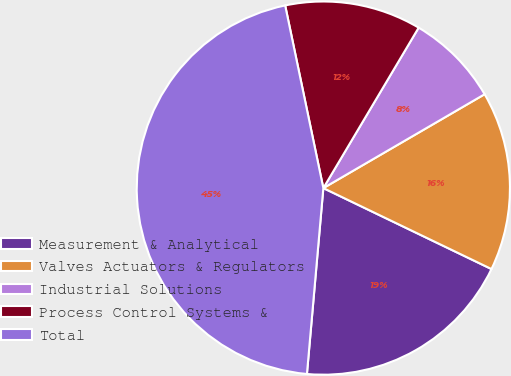<chart> <loc_0><loc_0><loc_500><loc_500><pie_chart><fcel>Measurement & Analytical<fcel>Valves Actuators & Regulators<fcel>Industrial Solutions<fcel>Process Control Systems &<fcel>Total<nl><fcel>19.26%<fcel>15.53%<fcel>8.08%<fcel>11.81%<fcel>45.32%<nl></chart> 